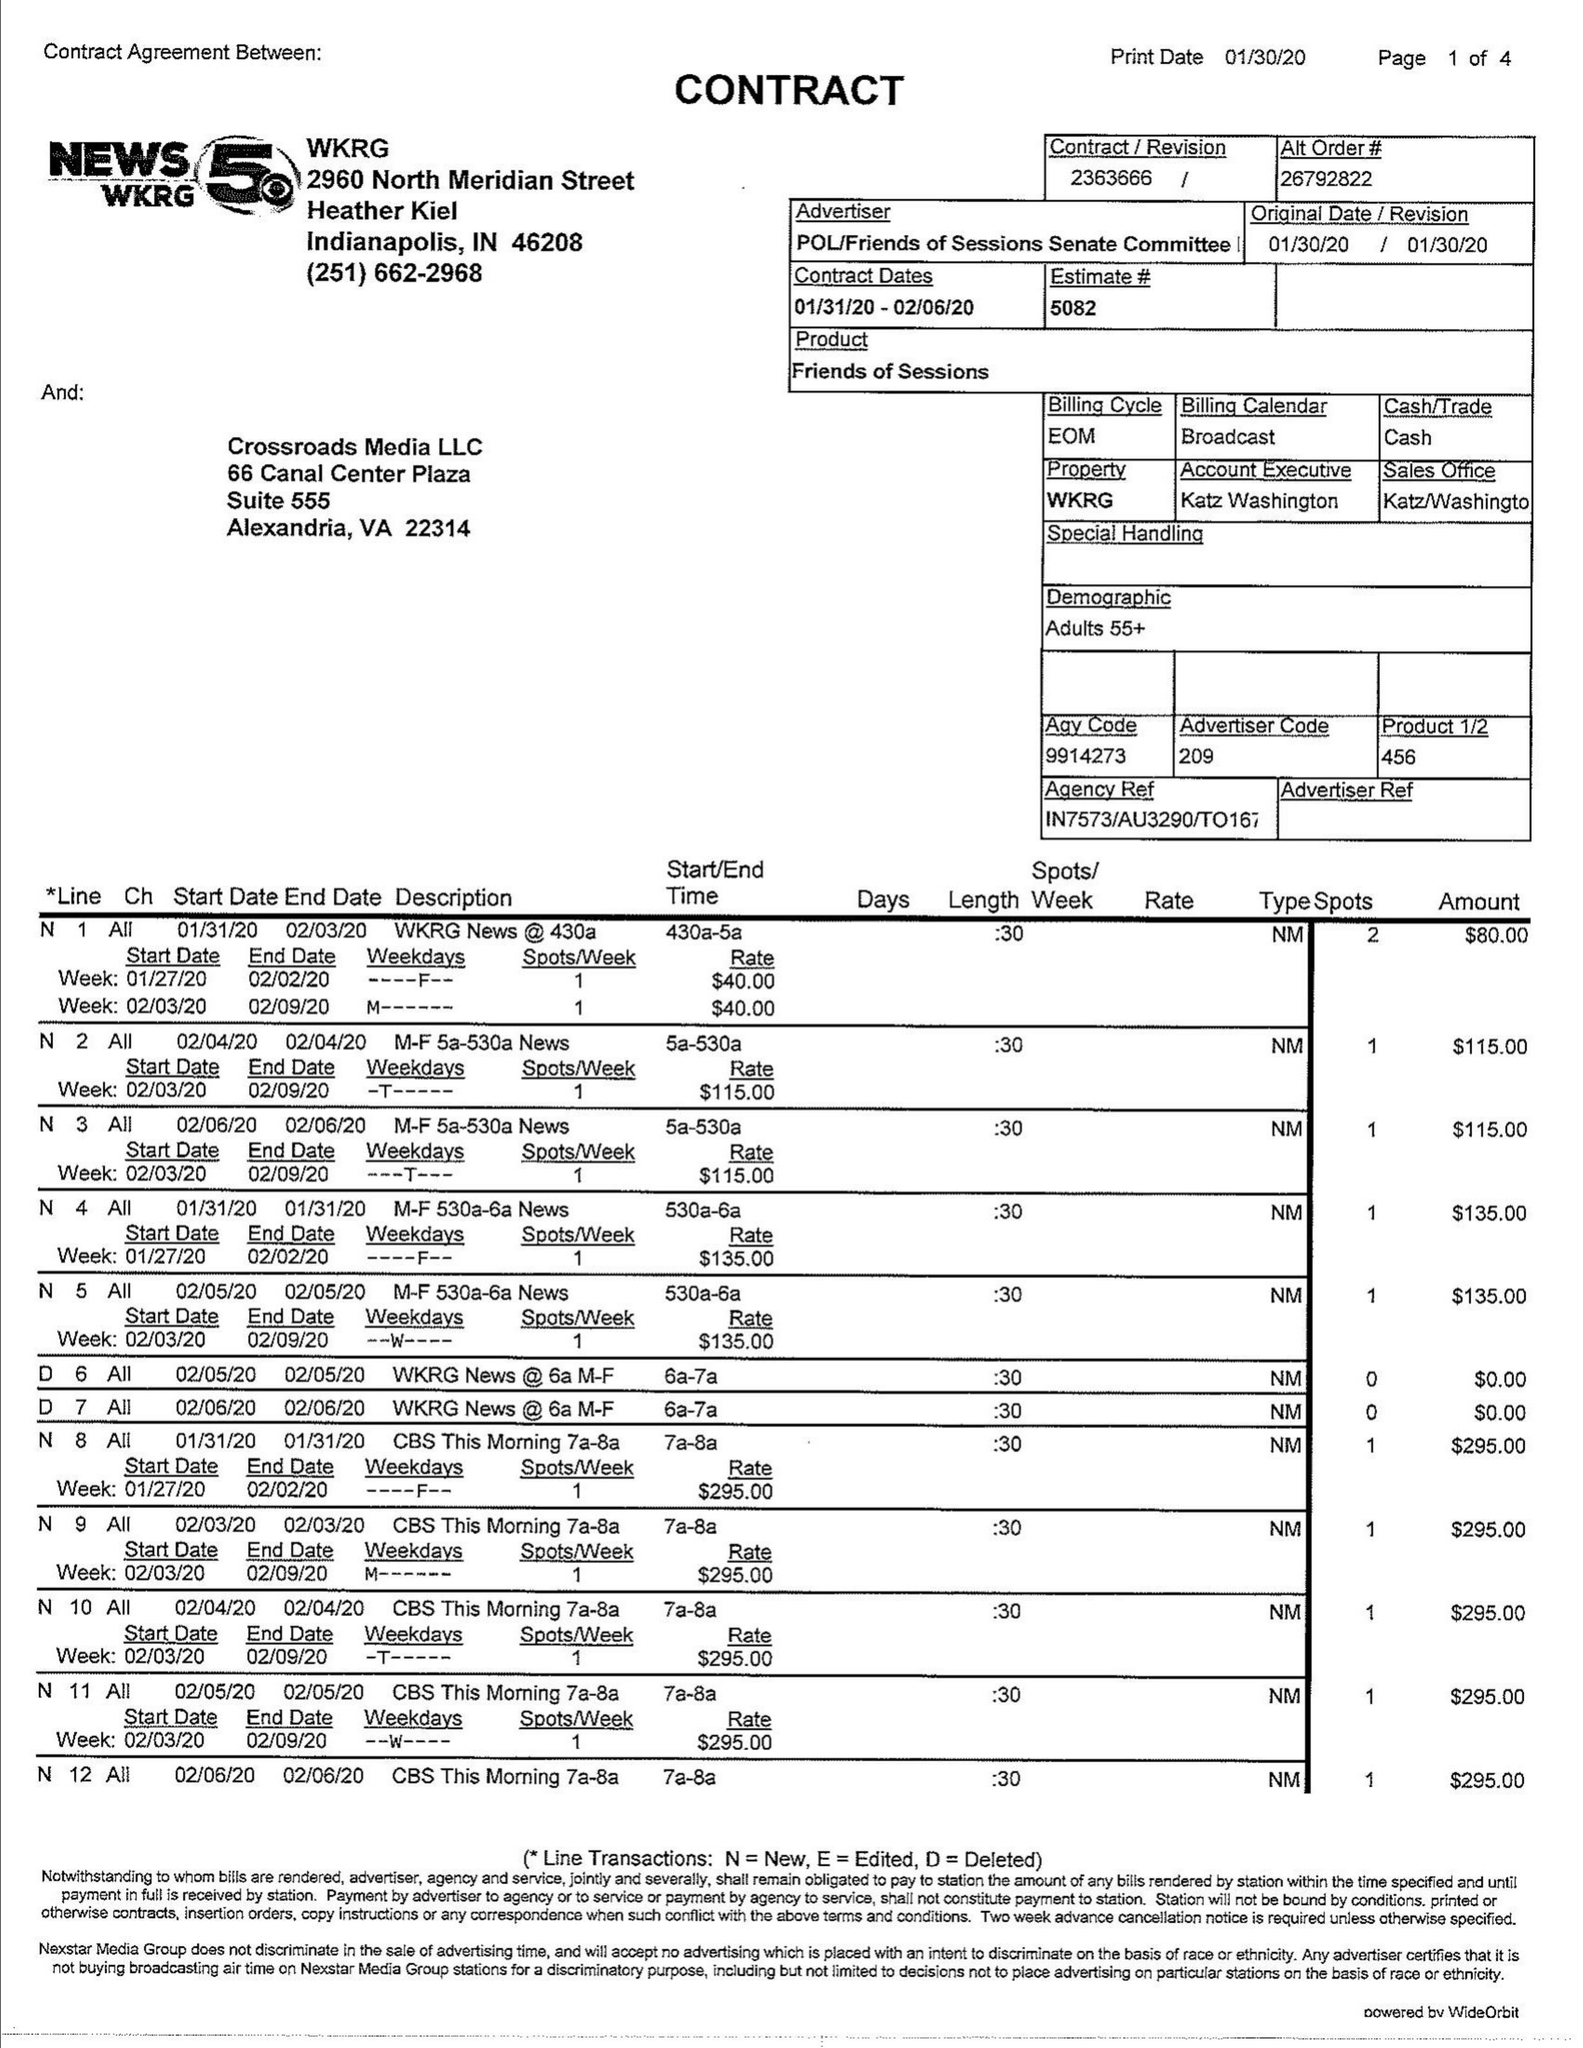What is the value for the contract_num?
Answer the question using a single word or phrase. 2363666 